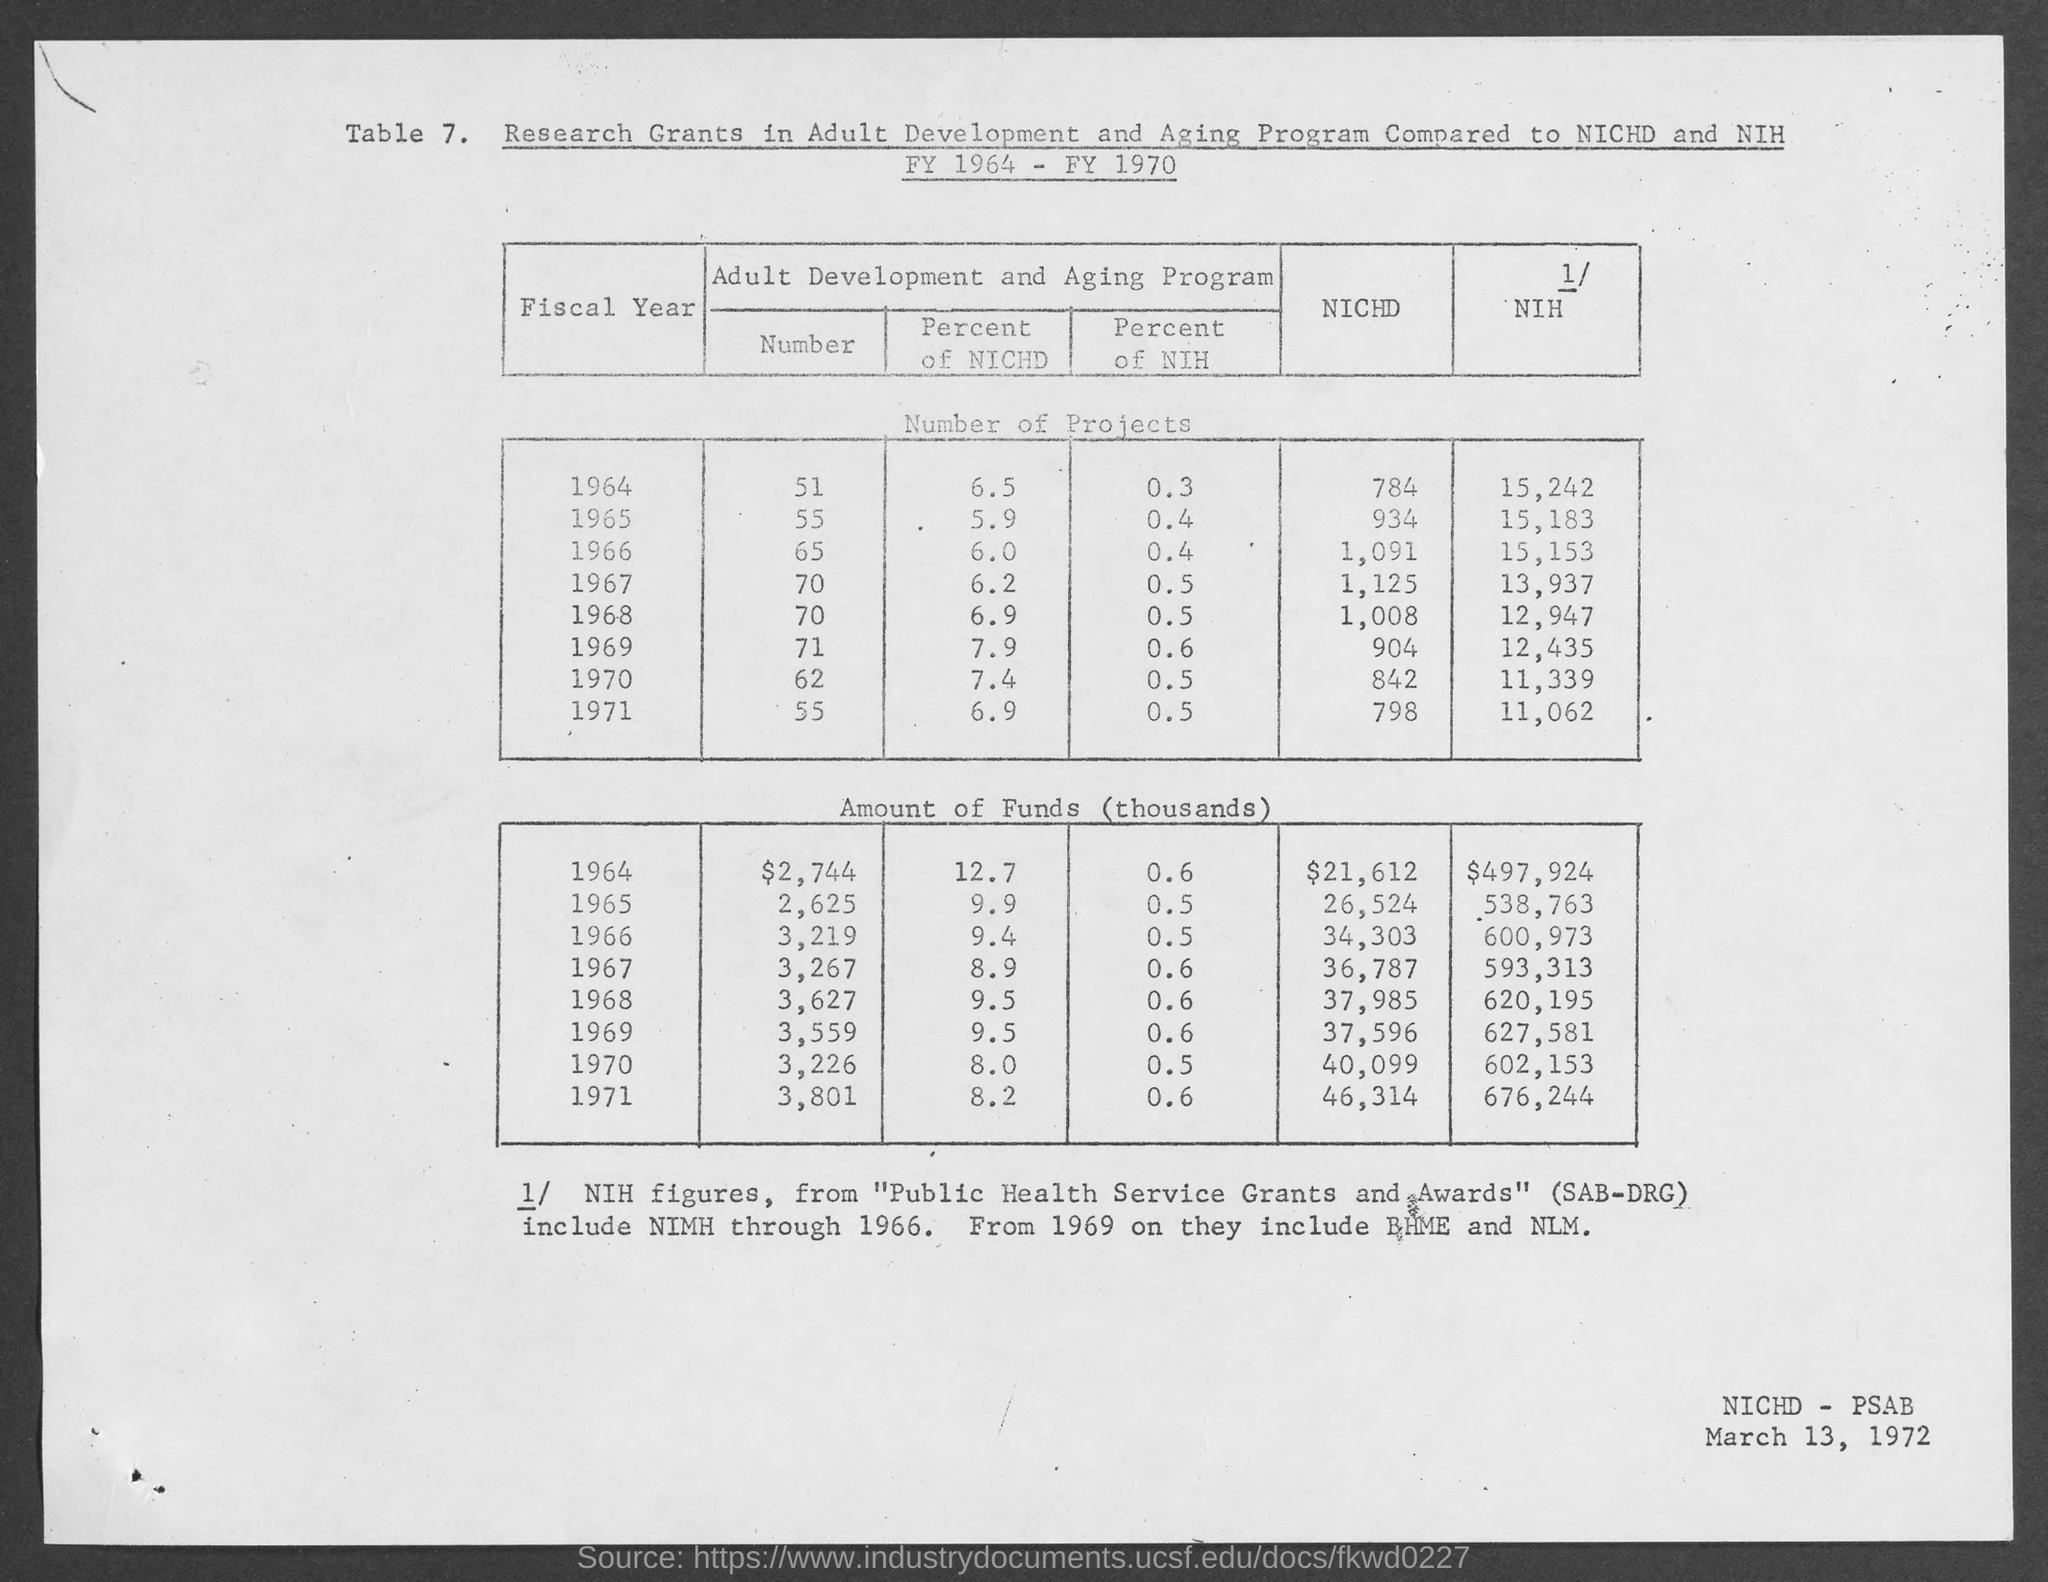What is the table no.?
Your answer should be compact. 7. What is the date at bottom- right corner of the page ?
Make the answer very short. March 13, 1972. 